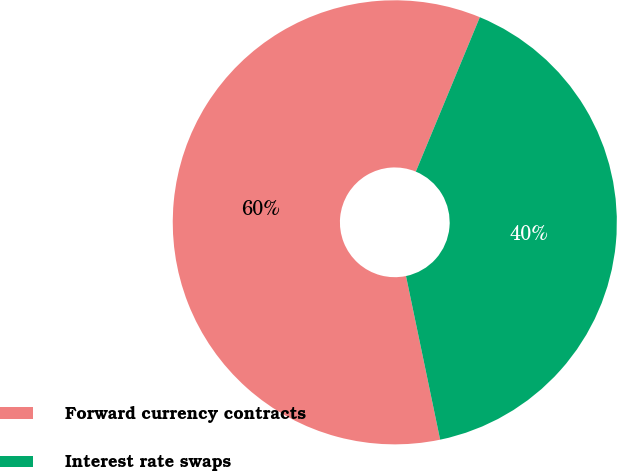<chart> <loc_0><loc_0><loc_500><loc_500><pie_chart><fcel>Forward currency contracts<fcel>Interest rate swaps<nl><fcel>59.53%<fcel>40.47%<nl></chart> 